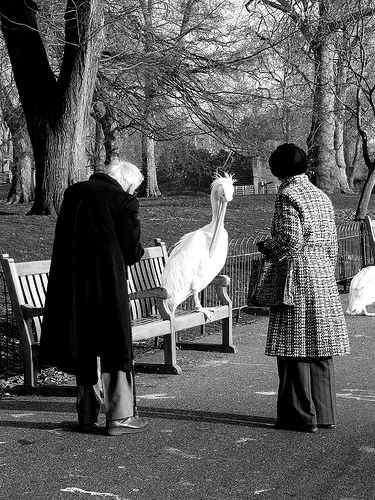Please provide a short description for this region: [0.53, 0.4, 0.58, 0.51]. A white bird with a very long beak is standing on a bench. 